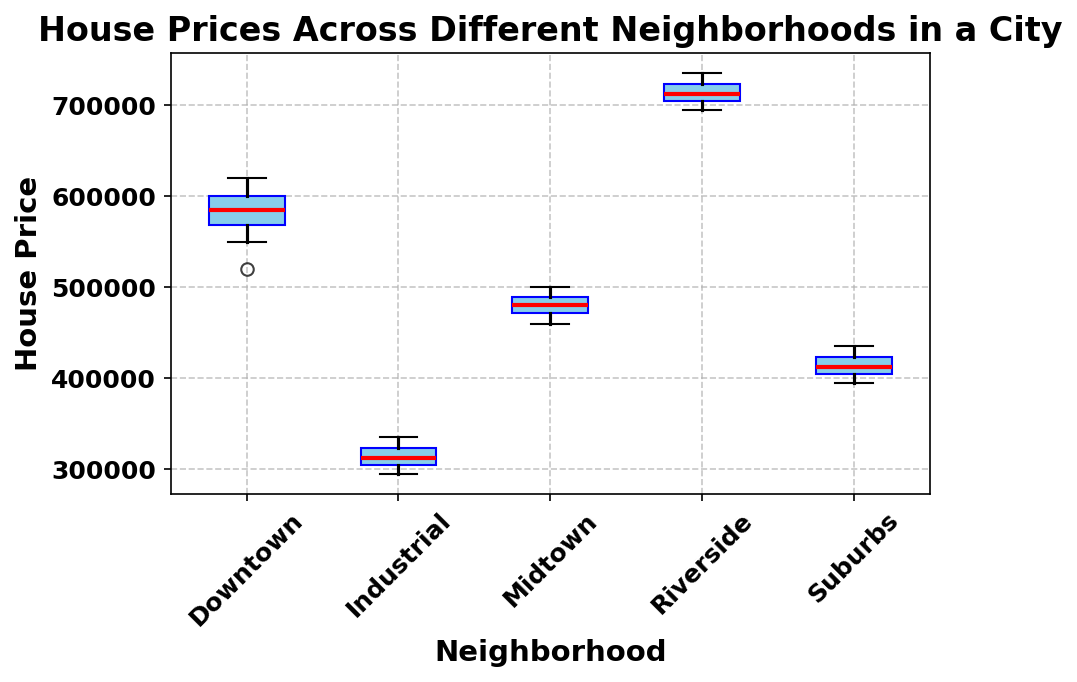Which neighborhood has the highest median house price? To determine the highest median house price, look for the red line (median) inside each box. The red line in the Riverside box is visually the highest on the y-axis.
Answer: Riverside Which neighborhood has the lowest median house price? To find the lowest median house price, observe the red lines (medians) inside each box. The red line in the Industrial box is visually the lowest on the y-axis.
Answer: Industrial What is the interquartile range (IQR) of house prices in the Suburbs? The IQR is the difference between the third quartile (top edge of the box) and the first quartile (bottom edge of the box). By comparing the positions of these edges on the y-axis in the Suburbs box, estimate these values and subtract.
Answer: Approximately 30,000-40,000 Are there any neighborhoods with outliers, and if so, which ones? Outliers are marked by dots outside the whiskers in each box plot. Scan each neighborhood's box; there are no dots outside the whiskers, so there are no outliers.
Answer: None How does the spread of house prices in Downtown compare to those in the Industrial area? The spread can be assessed by the height of the boxes and whiskers. The Downtown box and whiskers span a taller y-range compared to those of the Industrial, indicating a larger spread.
Answer: Downtown has a larger spread Which neighborhood shows the most consistent house prices? Consistency is indicated by a smaller spread in the box plot (narrow boxes and shorter whiskers). The Industrial box has the smallest spread, indicating more consistent house prices.
Answer: Industrial Compare the upper whisker lengths of Riverside and Midtown. Which is longer and what does it indicate about house prices? The upper whisker length indicates the range from the third quartile to the maximum value. The Riverside upper whisker is longer than the Midtown upper whisker, indicating a larger range in higher house prices.
Answer: Riverside What is the approximate range of house prices in Midtown? The range is the difference between the maximum and minimum values, indicated by the top and bottom ends of the whiskers. Estimate these values on the y-axis for Midtown and calculate the difference.
Answer: Approximately 460,000 to 500,000 How does the median house price in the Suburbs compare to that in Riverside? Compare the red lines (medians) inside the boxes for both Suburbs and Riverside. The median in Riverside is visually much higher than that in Suburbs.
Answer: Riverside's median is higher What can you infer about the variability of house prices in Downtown compared to the Suburbs? Variability is indicated by the size of the IQR (height of the box) and the length of the whiskers. Downtown shows a larger IQR and whiskers compared to Suburbs, indicating higher variability in house prices.
Answer: Downtown has higher variability 